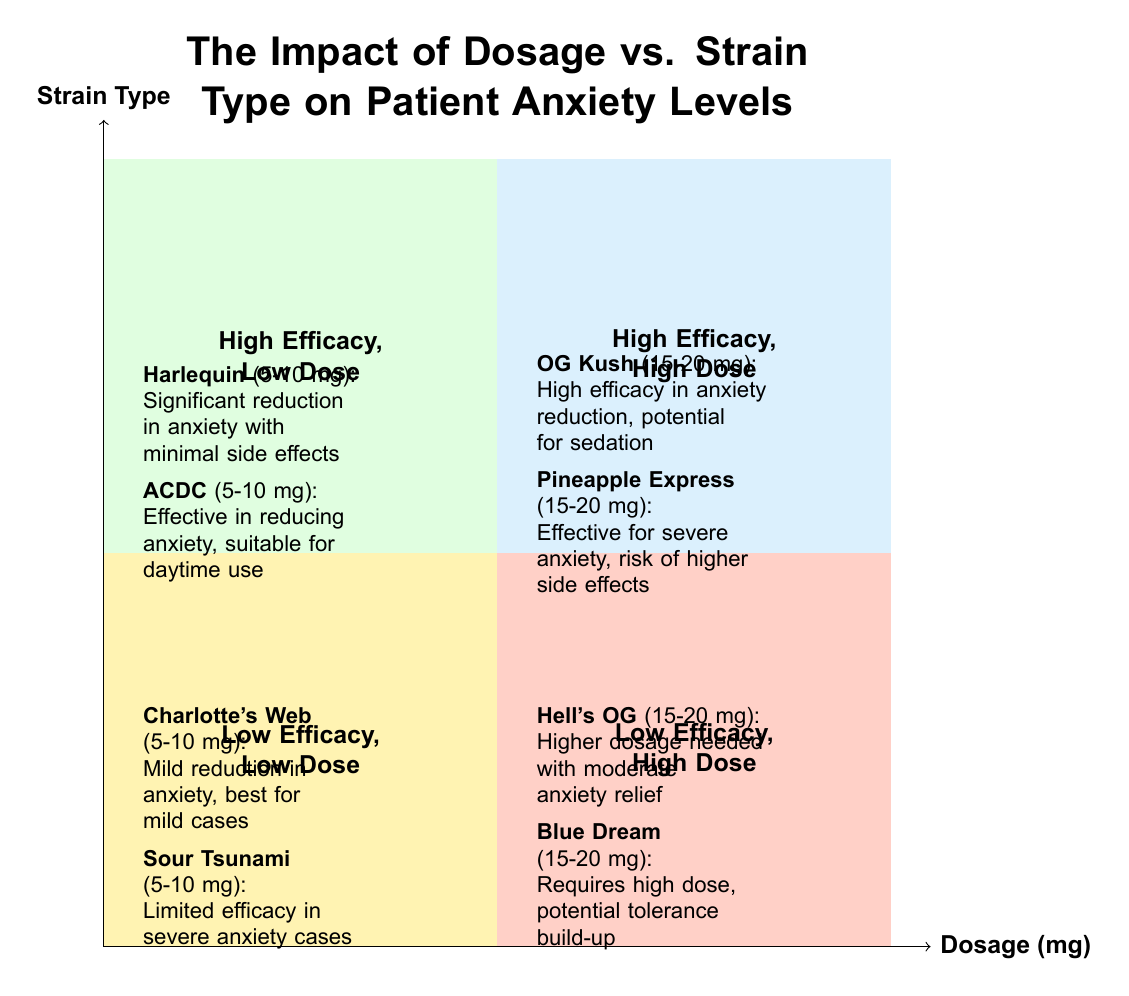What are the two strains listed in the "High Efficacy, Low Dose" quadrant? The diagram shows two strains in the "High Efficacy, Low Dose" quadrant: "Harlequin" and "ACDC."
Answer: Harlequin and ACDC Which quadrant contains "Hell's OG"? "Hell's OG" is listed in the "Low Efficacy, High Dose" quadrant, as per the diagram.
Answer: Low Efficacy, High Dose What is the dosage range for "OG Kush"? The dosage for "OG Kush" is specified as 15-20 mg in the "High Efficacy, High Dose" quadrant of the diagram.
Answer: 15-20 mg How many strains are identified in the "Low Efficacy, Low Dose" quadrant? There are two strains identified in the "Low Efficacy, Low Dose" quadrant: "Charlotte's Web" and "Sour Tsunami."
Answer: 2 What is the key characteristic of the "High Efficacy, High Dose" quadrant? The key characteristic of this quadrant is that it requires a high dosage for significant anxiety reduction.
Answer: High dosage required Which strain in the "Low Efficacy, High Dose" quadrant has a risk of tolerance build-up? The strain "Blue Dream" in the "Low Efficacy, High Dose" quadrant is noted for the potential risk of tolerance build-up.
Answer: Blue Dream What impacts does "Pineapple Express" have according to the diagram? "Pineapple Express" is noted to be effective for severe anxiety but carries a risk of higher side effects, as indicated in the diagram.
Answer: Effective for severe anxiety, risk of higher side effects What distinguishes the "High Efficacy, Low Dose" quadrant from the "Low Efficacy, Low Dose" quadrant? The "High Efficacy, Low Dose" quadrant has strains that provide significant anxiety reduction with minimal side effects, while the "Low Efficacy, Low Dose" quadrant shows limited impact on anxiety reduction.
Answer: Significant reduction vs. limited impact 